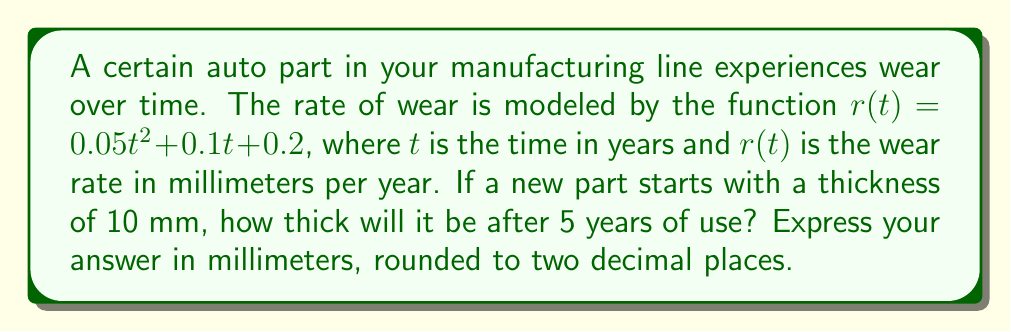Show me your answer to this math problem. To solve this problem, we need to use integral equations to model the total wear over time:

1) The total wear after 5 years is given by the integral of the wear rate function from 0 to 5:

   $$W = \int_0^5 r(t) dt = \int_0^5 (0.05t^2 + 0.1t + 0.2) dt$$

2) Let's solve this integral:

   $$W = \left[0.05\frac{t^3}{3} + 0.1\frac{t^2}{2} + 0.2t\right]_0^5$$

3) Evaluate the integral:

   $$W = \left(0.05\frac{5^3}{3} + 0.1\frac{5^2}{2} + 0.2(5)\right) - \left(0.05\frac{0^3}{3} + 0.1\frac{0^2}{2} + 0.2(0)\right)$$

4) Simplify:

   $$W = (2.0833 + 1.25 + 1) - 0 = 4.3333$$

5) The total wear after 5 years is approximately 4.33 mm.

6) Since the part started with a thickness of 10 mm, the remaining thickness is:

   $$10 - 4.33 = 5.67 \text{ mm}$$

Rounding to two decimal places, we get 5.67 mm.
Answer: 5.67 mm 